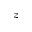<formula> <loc_0><loc_0><loc_500><loc_500>z</formula> 